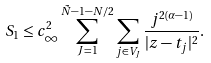<formula> <loc_0><loc_0><loc_500><loc_500>S _ { 1 } \leq c _ { \infty } ^ { 2 } \sum _ { J = 1 } ^ { \tilde { N } - 1 - N / 2 } \sum _ { j \in V _ { J } } \frac { j ^ { 2 ( \alpha - 1 ) } } { | z - t _ { j } | ^ { 2 } } .</formula> 